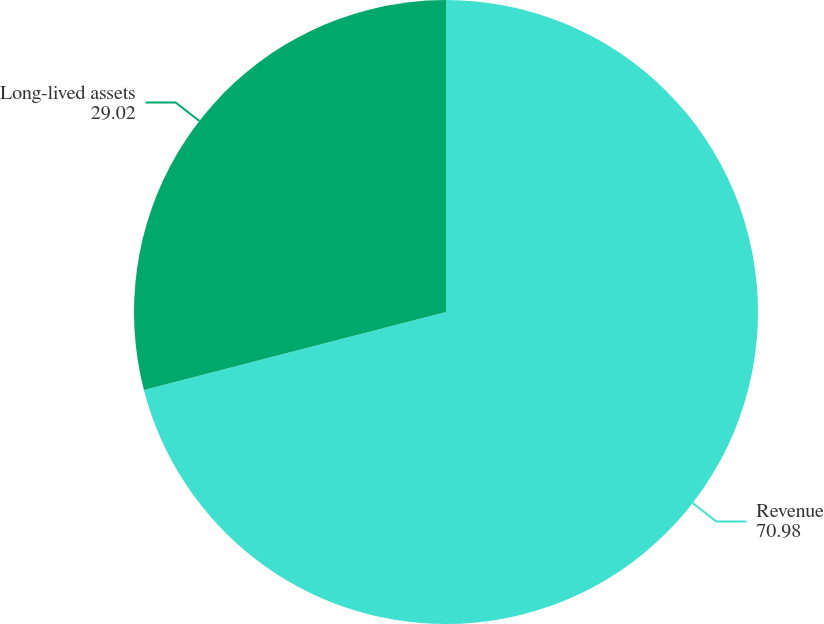Convert chart to OTSL. <chart><loc_0><loc_0><loc_500><loc_500><pie_chart><fcel>Revenue<fcel>Long-lived assets<nl><fcel>70.98%<fcel>29.02%<nl></chart> 